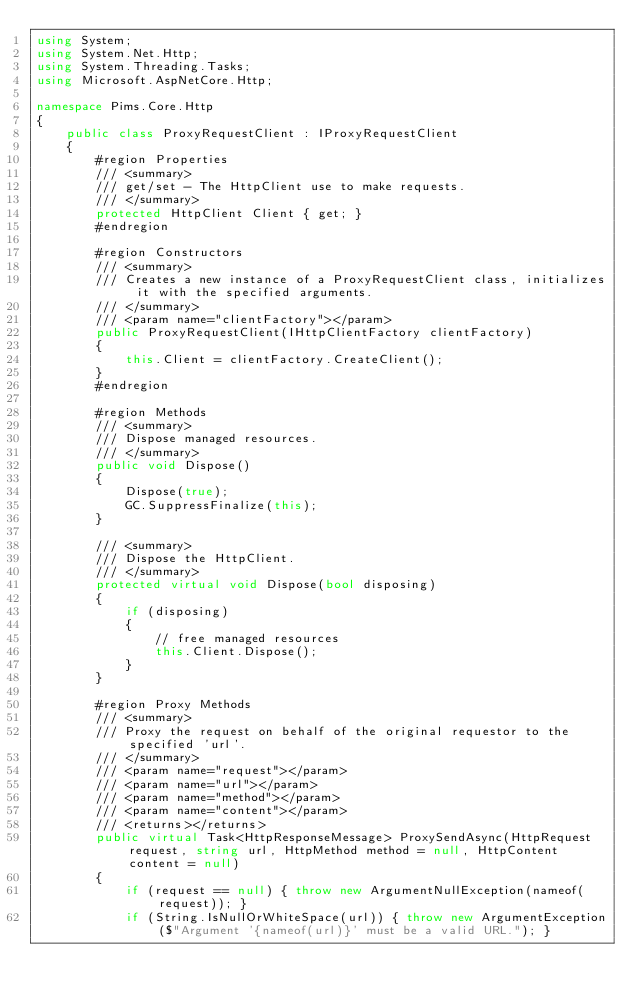<code> <loc_0><loc_0><loc_500><loc_500><_C#_>using System;
using System.Net.Http;
using System.Threading.Tasks;
using Microsoft.AspNetCore.Http;

namespace Pims.Core.Http
{
    public class ProxyRequestClient : IProxyRequestClient
    {
        #region Properties
        /// <summary>
        /// get/set - The HttpClient use to make requests.
        /// </summary>
        protected HttpClient Client { get; }
        #endregion

        #region Constructors
        /// <summary>
        /// Creates a new instance of a ProxyRequestClient class, initializes it with the specified arguments.
        /// </summary>
        /// <param name="clientFactory"></param>
        public ProxyRequestClient(IHttpClientFactory clientFactory)
        {
            this.Client = clientFactory.CreateClient();
        }
        #endregion

        #region Methods
        /// <summary>
        /// Dispose managed resources.
        /// </summary>
        public void Dispose()
        {
            Dispose(true);
            GC.SuppressFinalize(this);
        }

        /// <summary>
        /// Dispose the HttpClient.
        /// </summary>
        protected virtual void Dispose(bool disposing)
        {
            if (disposing)
            {
                // free managed resources
                this.Client.Dispose();
            }
        }

        #region Proxy Methods
        /// <summary>
        /// Proxy the request on behalf of the original requestor to the specified 'url'.
        /// </summary>
        /// <param name="request"></param>
        /// <param name="url"></param>
        /// <param name="method"></param>
        /// <param name="content"></param>
        /// <returns></returns>
        public virtual Task<HttpResponseMessage> ProxySendAsync(HttpRequest request, string url, HttpMethod method = null, HttpContent content = null)
        {
            if (request == null) { throw new ArgumentNullException(nameof(request)); }
            if (String.IsNullOrWhiteSpace(url)) { throw new ArgumentException($"Argument '{nameof(url)}' must be a valid URL."); }
</code> 